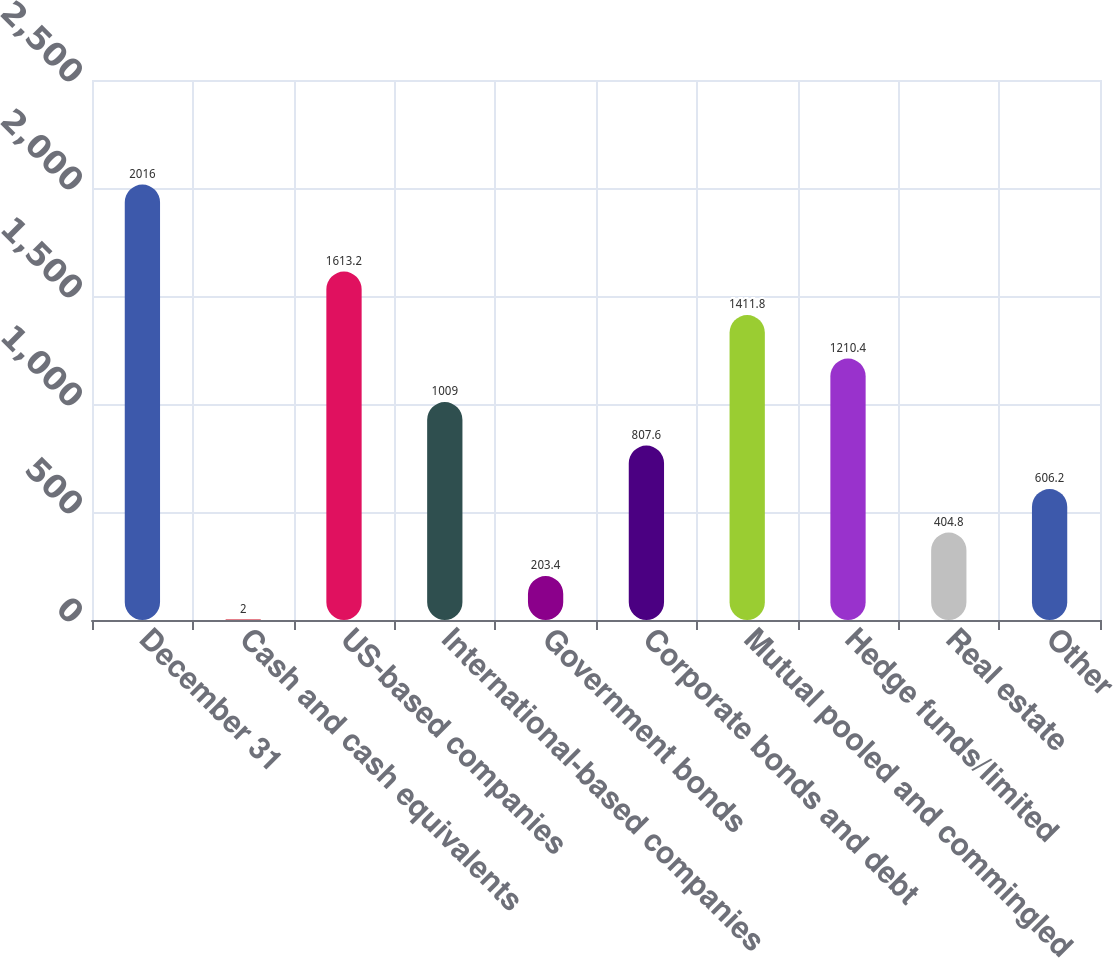<chart> <loc_0><loc_0><loc_500><loc_500><bar_chart><fcel>December 31<fcel>Cash and cash equivalents<fcel>US-based companies<fcel>International-based companies<fcel>Government bonds<fcel>Corporate bonds and debt<fcel>Mutual pooled and commingled<fcel>Hedge funds/limited<fcel>Real estate<fcel>Other<nl><fcel>2016<fcel>2<fcel>1613.2<fcel>1009<fcel>203.4<fcel>807.6<fcel>1411.8<fcel>1210.4<fcel>404.8<fcel>606.2<nl></chart> 